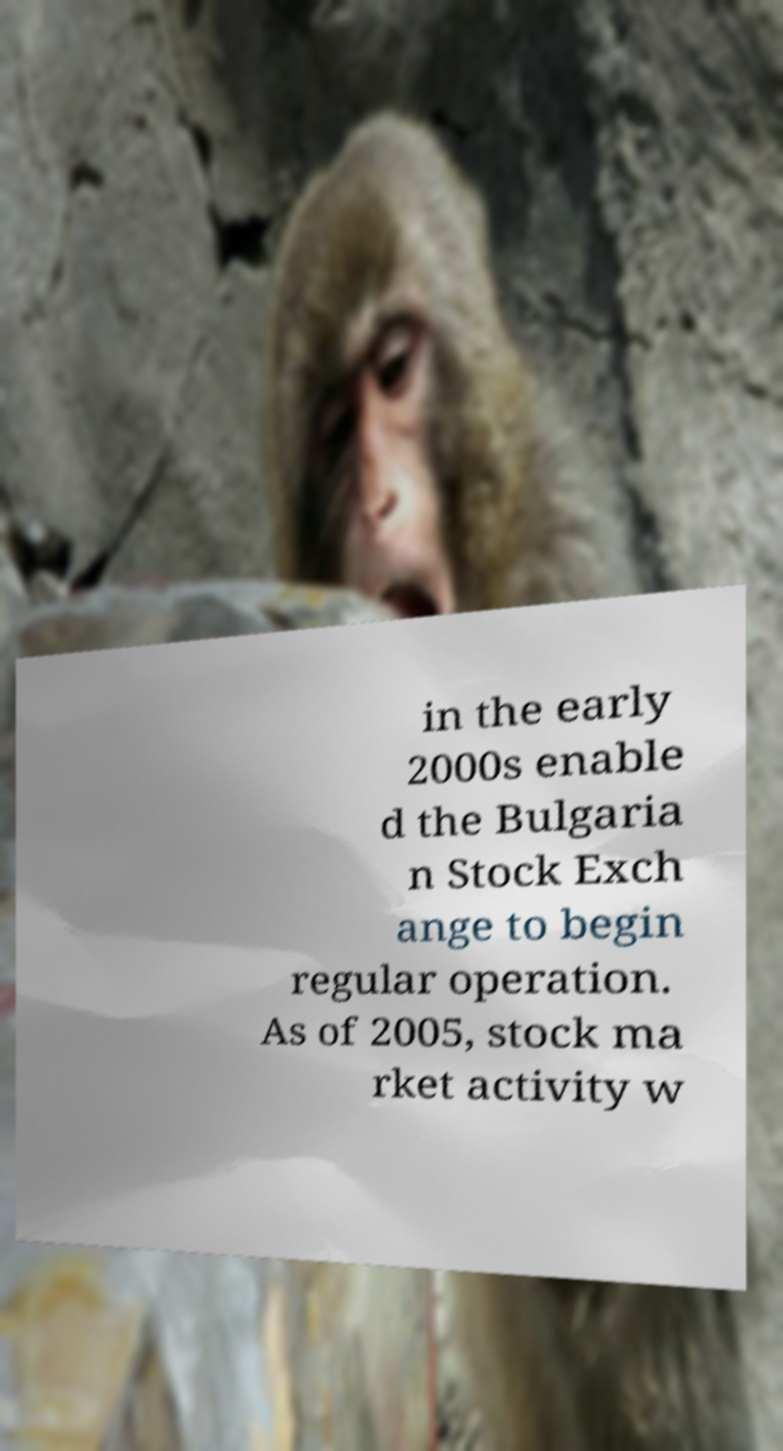Can you read and provide the text displayed in the image?This photo seems to have some interesting text. Can you extract and type it out for me? in the early 2000s enable d the Bulgaria n Stock Exch ange to begin regular operation. As of 2005, stock ma rket activity w 